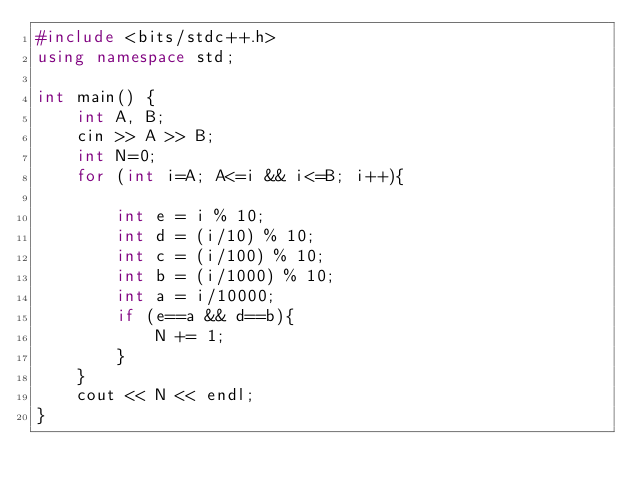Convert code to text. <code><loc_0><loc_0><loc_500><loc_500><_C++_>#include <bits/stdc++.h>
using namespace std;
 
int main() {
    int A, B;
    cin >> A >> B;
    int N=0;
    for (int i=A; A<=i && i<=B; i++){

        int e = i % 10;
        int d = (i/10) % 10;
        int c = (i/100) % 10;
        int b = (i/1000) % 10;
        int a = i/10000;
        if (e==a && d==b){
            N += 1;
        }
    }
    cout << N << endl;
}</code> 